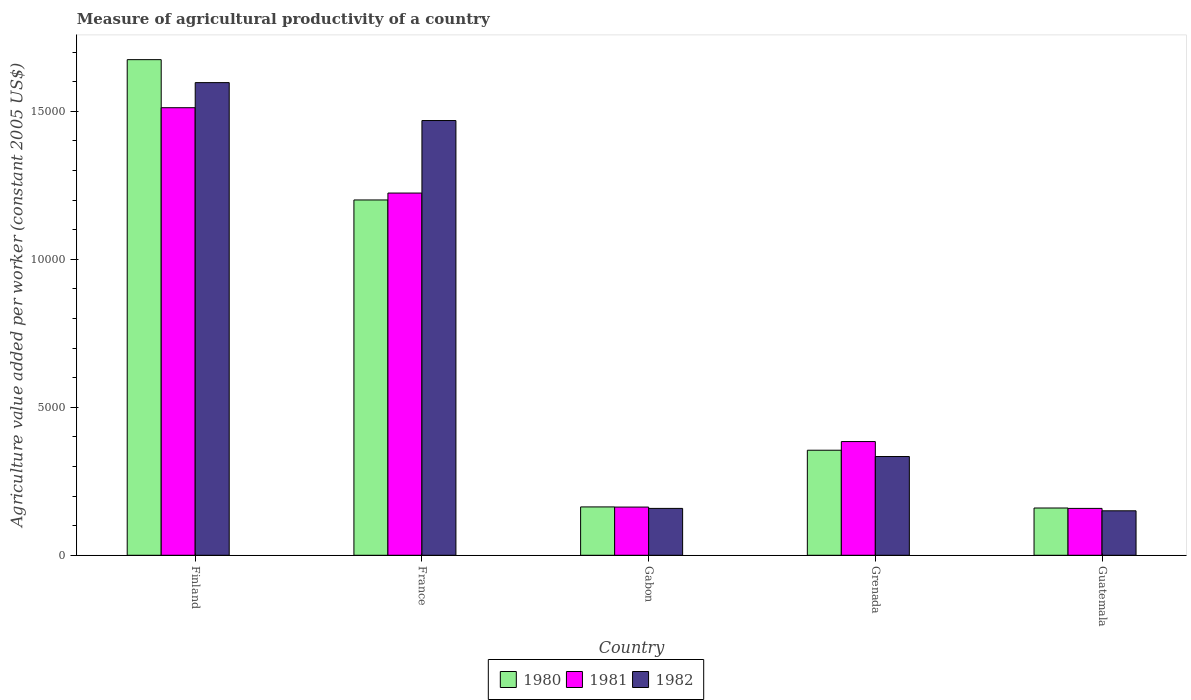How many different coloured bars are there?
Keep it short and to the point. 3. How many groups of bars are there?
Make the answer very short. 5. How many bars are there on the 5th tick from the left?
Provide a short and direct response. 3. How many bars are there on the 4th tick from the right?
Make the answer very short. 3. What is the label of the 2nd group of bars from the left?
Keep it short and to the point. France. What is the measure of agricultural productivity in 1982 in Grenada?
Make the answer very short. 3337.18. Across all countries, what is the maximum measure of agricultural productivity in 1980?
Your answer should be very brief. 1.67e+04. Across all countries, what is the minimum measure of agricultural productivity in 1980?
Your response must be concise. 1597.56. In which country was the measure of agricultural productivity in 1980 maximum?
Offer a very short reply. Finland. In which country was the measure of agricultural productivity in 1982 minimum?
Your answer should be compact. Guatemala. What is the total measure of agricultural productivity in 1982 in the graph?
Offer a very short reply. 3.71e+04. What is the difference between the measure of agricultural productivity in 1980 in France and that in Grenada?
Provide a succinct answer. 8457.31. What is the difference between the measure of agricultural productivity in 1982 in Gabon and the measure of agricultural productivity in 1980 in Grenada?
Ensure brevity in your answer.  -1966.16. What is the average measure of agricultural productivity in 1980 per country?
Keep it short and to the point. 7107.71. What is the difference between the measure of agricultural productivity of/in 1982 and measure of agricultural productivity of/in 1980 in France?
Your response must be concise. 2683.77. What is the ratio of the measure of agricultural productivity in 1981 in Finland to that in France?
Keep it short and to the point. 1.24. Is the measure of agricultural productivity in 1981 in Finland less than that in France?
Your answer should be compact. No. What is the difference between the highest and the second highest measure of agricultural productivity in 1980?
Your answer should be compact. 1.32e+04. What is the difference between the highest and the lowest measure of agricultural productivity in 1980?
Your answer should be compact. 1.52e+04. In how many countries, is the measure of agricultural productivity in 1980 greater than the average measure of agricultural productivity in 1980 taken over all countries?
Your answer should be very brief. 2. Is it the case that in every country, the sum of the measure of agricultural productivity in 1982 and measure of agricultural productivity in 1980 is greater than the measure of agricultural productivity in 1981?
Give a very brief answer. Yes. How many bars are there?
Provide a short and direct response. 15. How many countries are there in the graph?
Give a very brief answer. 5. Are the values on the major ticks of Y-axis written in scientific E-notation?
Keep it short and to the point. No. Where does the legend appear in the graph?
Your answer should be compact. Bottom center. How many legend labels are there?
Offer a very short reply. 3. What is the title of the graph?
Give a very brief answer. Measure of agricultural productivity of a country. What is the label or title of the X-axis?
Keep it short and to the point. Country. What is the label or title of the Y-axis?
Provide a succinct answer. Agriculture value added per worker (constant 2005 US$). What is the Agriculture value added per worker (constant 2005 US$) of 1980 in Finland?
Your response must be concise. 1.67e+04. What is the Agriculture value added per worker (constant 2005 US$) of 1981 in Finland?
Provide a succinct answer. 1.51e+04. What is the Agriculture value added per worker (constant 2005 US$) of 1982 in Finland?
Ensure brevity in your answer.  1.60e+04. What is the Agriculture value added per worker (constant 2005 US$) of 1980 in France?
Offer a very short reply. 1.20e+04. What is the Agriculture value added per worker (constant 2005 US$) in 1981 in France?
Your response must be concise. 1.22e+04. What is the Agriculture value added per worker (constant 2005 US$) in 1982 in France?
Ensure brevity in your answer.  1.47e+04. What is the Agriculture value added per worker (constant 2005 US$) in 1980 in Gabon?
Your answer should be very brief. 1634.34. What is the Agriculture value added per worker (constant 2005 US$) of 1981 in Gabon?
Your answer should be very brief. 1629.22. What is the Agriculture value added per worker (constant 2005 US$) of 1982 in Gabon?
Your answer should be compact. 1584.05. What is the Agriculture value added per worker (constant 2005 US$) of 1980 in Grenada?
Offer a very short reply. 3550.21. What is the Agriculture value added per worker (constant 2005 US$) of 1981 in Grenada?
Keep it short and to the point. 3843.2. What is the Agriculture value added per worker (constant 2005 US$) in 1982 in Grenada?
Your answer should be compact. 3337.18. What is the Agriculture value added per worker (constant 2005 US$) of 1980 in Guatemala?
Make the answer very short. 1597.56. What is the Agriculture value added per worker (constant 2005 US$) of 1981 in Guatemala?
Provide a short and direct response. 1584.31. What is the Agriculture value added per worker (constant 2005 US$) in 1982 in Guatemala?
Your response must be concise. 1502.82. Across all countries, what is the maximum Agriculture value added per worker (constant 2005 US$) in 1980?
Offer a terse response. 1.67e+04. Across all countries, what is the maximum Agriculture value added per worker (constant 2005 US$) in 1981?
Keep it short and to the point. 1.51e+04. Across all countries, what is the maximum Agriculture value added per worker (constant 2005 US$) in 1982?
Ensure brevity in your answer.  1.60e+04. Across all countries, what is the minimum Agriculture value added per worker (constant 2005 US$) of 1980?
Provide a short and direct response. 1597.56. Across all countries, what is the minimum Agriculture value added per worker (constant 2005 US$) in 1981?
Your response must be concise. 1584.31. Across all countries, what is the minimum Agriculture value added per worker (constant 2005 US$) in 1982?
Provide a succinct answer. 1502.82. What is the total Agriculture value added per worker (constant 2005 US$) in 1980 in the graph?
Offer a terse response. 3.55e+04. What is the total Agriculture value added per worker (constant 2005 US$) of 1981 in the graph?
Keep it short and to the point. 3.44e+04. What is the total Agriculture value added per worker (constant 2005 US$) in 1982 in the graph?
Your answer should be compact. 3.71e+04. What is the difference between the Agriculture value added per worker (constant 2005 US$) of 1980 in Finland and that in France?
Your response must be concise. 4741.4. What is the difference between the Agriculture value added per worker (constant 2005 US$) of 1981 in Finland and that in France?
Offer a terse response. 2884.02. What is the difference between the Agriculture value added per worker (constant 2005 US$) of 1982 in Finland and that in France?
Offer a terse response. 1281.43. What is the difference between the Agriculture value added per worker (constant 2005 US$) in 1980 in Finland and that in Gabon?
Your answer should be compact. 1.51e+04. What is the difference between the Agriculture value added per worker (constant 2005 US$) of 1981 in Finland and that in Gabon?
Provide a short and direct response. 1.35e+04. What is the difference between the Agriculture value added per worker (constant 2005 US$) of 1982 in Finland and that in Gabon?
Your answer should be compact. 1.44e+04. What is the difference between the Agriculture value added per worker (constant 2005 US$) of 1980 in Finland and that in Grenada?
Offer a very short reply. 1.32e+04. What is the difference between the Agriculture value added per worker (constant 2005 US$) of 1981 in Finland and that in Grenada?
Provide a short and direct response. 1.13e+04. What is the difference between the Agriculture value added per worker (constant 2005 US$) in 1982 in Finland and that in Grenada?
Offer a terse response. 1.26e+04. What is the difference between the Agriculture value added per worker (constant 2005 US$) of 1980 in Finland and that in Guatemala?
Keep it short and to the point. 1.52e+04. What is the difference between the Agriculture value added per worker (constant 2005 US$) of 1981 in Finland and that in Guatemala?
Offer a terse response. 1.35e+04. What is the difference between the Agriculture value added per worker (constant 2005 US$) in 1982 in Finland and that in Guatemala?
Keep it short and to the point. 1.45e+04. What is the difference between the Agriculture value added per worker (constant 2005 US$) of 1980 in France and that in Gabon?
Your answer should be very brief. 1.04e+04. What is the difference between the Agriculture value added per worker (constant 2005 US$) in 1981 in France and that in Gabon?
Your answer should be very brief. 1.06e+04. What is the difference between the Agriculture value added per worker (constant 2005 US$) in 1982 in France and that in Gabon?
Give a very brief answer. 1.31e+04. What is the difference between the Agriculture value added per worker (constant 2005 US$) in 1980 in France and that in Grenada?
Your answer should be compact. 8457.31. What is the difference between the Agriculture value added per worker (constant 2005 US$) in 1981 in France and that in Grenada?
Offer a terse response. 8397.81. What is the difference between the Agriculture value added per worker (constant 2005 US$) in 1982 in France and that in Grenada?
Provide a succinct answer. 1.14e+04. What is the difference between the Agriculture value added per worker (constant 2005 US$) of 1980 in France and that in Guatemala?
Provide a short and direct response. 1.04e+04. What is the difference between the Agriculture value added per worker (constant 2005 US$) in 1981 in France and that in Guatemala?
Offer a terse response. 1.07e+04. What is the difference between the Agriculture value added per worker (constant 2005 US$) of 1982 in France and that in Guatemala?
Make the answer very short. 1.32e+04. What is the difference between the Agriculture value added per worker (constant 2005 US$) in 1980 in Gabon and that in Grenada?
Your response must be concise. -1915.87. What is the difference between the Agriculture value added per worker (constant 2005 US$) of 1981 in Gabon and that in Grenada?
Provide a short and direct response. -2213.98. What is the difference between the Agriculture value added per worker (constant 2005 US$) in 1982 in Gabon and that in Grenada?
Your response must be concise. -1753.13. What is the difference between the Agriculture value added per worker (constant 2005 US$) in 1980 in Gabon and that in Guatemala?
Keep it short and to the point. 36.78. What is the difference between the Agriculture value added per worker (constant 2005 US$) of 1981 in Gabon and that in Guatemala?
Your response must be concise. 44.92. What is the difference between the Agriculture value added per worker (constant 2005 US$) in 1982 in Gabon and that in Guatemala?
Provide a succinct answer. 81.23. What is the difference between the Agriculture value added per worker (constant 2005 US$) in 1980 in Grenada and that in Guatemala?
Your response must be concise. 1952.65. What is the difference between the Agriculture value added per worker (constant 2005 US$) in 1981 in Grenada and that in Guatemala?
Make the answer very short. 2258.89. What is the difference between the Agriculture value added per worker (constant 2005 US$) in 1982 in Grenada and that in Guatemala?
Give a very brief answer. 1834.36. What is the difference between the Agriculture value added per worker (constant 2005 US$) in 1980 in Finland and the Agriculture value added per worker (constant 2005 US$) in 1981 in France?
Your answer should be compact. 4507.91. What is the difference between the Agriculture value added per worker (constant 2005 US$) of 1980 in Finland and the Agriculture value added per worker (constant 2005 US$) of 1982 in France?
Offer a very short reply. 2057.63. What is the difference between the Agriculture value added per worker (constant 2005 US$) in 1981 in Finland and the Agriculture value added per worker (constant 2005 US$) in 1982 in France?
Your answer should be very brief. 433.74. What is the difference between the Agriculture value added per worker (constant 2005 US$) of 1980 in Finland and the Agriculture value added per worker (constant 2005 US$) of 1981 in Gabon?
Your answer should be compact. 1.51e+04. What is the difference between the Agriculture value added per worker (constant 2005 US$) in 1980 in Finland and the Agriculture value added per worker (constant 2005 US$) in 1982 in Gabon?
Keep it short and to the point. 1.52e+04. What is the difference between the Agriculture value added per worker (constant 2005 US$) of 1981 in Finland and the Agriculture value added per worker (constant 2005 US$) of 1982 in Gabon?
Offer a terse response. 1.35e+04. What is the difference between the Agriculture value added per worker (constant 2005 US$) of 1980 in Finland and the Agriculture value added per worker (constant 2005 US$) of 1981 in Grenada?
Your answer should be very brief. 1.29e+04. What is the difference between the Agriculture value added per worker (constant 2005 US$) in 1980 in Finland and the Agriculture value added per worker (constant 2005 US$) in 1982 in Grenada?
Ensure brevity in your answer.  1.34e+04. What is the difference between the Agriculture value added per worker (constant 2005 US$) in 1981 in Finland and the Agriculture value added per worker (constant 2005 US$) in 1982 in Grenada?
Provide a short and direct response. 1.18e+04. What is the difference between the Agriculture value added per worker (constant 2005 US$) in 1980 in Finland and the Agriculture value added per worker (constant 2005 US$) in 1981 in Guatemala?
Your answer should be very brief. 1.52e+04. What is the difference between the Agriculture value added per worker (constant 2005 US$) of 1980 in Finland and the Agriculture value added per worker (constant 2005 US$) of 1982 in Guatemala?
Offer a very short reply. 1.52e+04. What is the difference between the Agriculture value added per worker (constant 2005 US$) in 1981 in Finland and the Agriculture value added per worker (constant 2005 US$) in 1982 in Guatemala?
Offer a very short reply. 1.36e+04. What is the difference between the Agriculture value added per worker (constant 2005 US$) in 1980 in France and the Agriculture value added per worker (constant 2005 US$) in 1981 in Gabon?
Your response must be concise. 1.04e+04. What is the difference between the Agriculture value added per worker (constant 2005 US$) of 1980 in France and the Agriculture value added per worker (constant 2005 US$) of 1982 in Gabon?
Your answer should be compact. 1.04e+04. What is the difference between the Agriculture value added per worker (constant 2005 US$) of 1981 in France and the Agriculture value added per worker (constant 2005 US$) of 1982 in Gabon?
Your answer should be very brief. 1.07e+04. What is the difference between the Agriculture value added per worker (constant 2005 US$) in 1980 in France and the Agriculture value added per worker (constant 2005 US$) in 1981 in Grenada?
Your response must be concise. 8164.32. What is the difference between the Agriculture value added per worker (constant 2005 US$) of 1980 in France and the Agriculture value added per worker (constant 2005 US$) of 1982 in Grenada?
Offer a terse response. 8670.34. What is the difference between the Agriculture value added per worker (constant 2005 US$) of 1981 in France and the Agriculture value added per worker (constant 2005 US$) of 1982 in Grenada?
Give a very brief answer. 8903.83. What is the difference between the Agriculture value added per worker (constant 2005 US$) of 1980 in France and the Agriculture value added per worker (constant 2005 US$) of 1981 in Guatemala?
Offer a very short reply. 1.04e+04. What is the difference between the Agriculture value added per worker (constant 2005 US$) of 1980 in France and the Agriculture value added per worker (constant 2005 US$) of 1982 in Guatemala?
Provide a short and direct response. 1.05e+04. What is the difference between the Agriculture value added per worker (constant 2005 US$) in 1981 in France and the Agriculture value added per worker (constant 2005 US$) in 1982 in Guatemala?
Make the answer very short. 1.07e+04. What is the difference between the Agriculture value added per worker (constant 2005 US$) in 1980 in Gabon and the Agriculture value added per worker (constant 2005 US$) in 1981 in Grenada?
Provide a succinct answer. -2208.86. What is the difference between the Agriculture value added per worker (constant 2005 US$) in 1980 in Gabon and the Agriculture value added per worker (constant 2005 US$) in 1982 in Grenada?
Ensure brevity in your answer.  -1702.83. What is the difference between the Agriculture value added per worker (constant 2005 US$) in 1981 in Gabon and the Agriculture value added per worker (constant 2005 US$) in 1982 in Grenada?
Ensure brevity in your answer.  -1707.95. What is the difference between the Agriculture value added per worker (constant 2005 US$) of 1980 in Gabon and the Agriculture value added per worker (constant 2005 US$) of 1981 in Guatemala?
Give a very brief answer. 50.04. What is the difference between the Agriculture value added per worker (constant 2005 US$) of 1980 in Gabon and the Agriculture value added per worker (constant 2005 US$) of 1982 in Guatemala?
Keep it short and to the point. 131.53. What is the difference between the Agriculture value added per worker (constant 2005 US$) of 1981 in Gabon and the Agriculture value added per worker (constant 2005 US$) of 1982 in Guatemala?
Offer a terse response. 126.41. What is the difference between the Agriculture value added per worker (constant 2005 US$) in 1980 in Grenada and the Agriculture value added per worker (constant 2005 US$) in 1981 in Guatemala?
Keep it short and to the point. 1965.91. What is the difference between the Agriculture value added per worker (constant 2005 US$) of 1980 in Grenada and the Agriculture value added per worker (constant 2005 US$) of 1982 in Guatemala?
Offer a very short reply. 2047.4. What is the difference between the Agriculture value added per worker (constant 2005 US$) of 1981 in Grenada and the Agriculture value added per worker (constant 2005 US$) of 1982 in Guatemala?
Provide a short and direct response. 2340.38. What is the average Agriculture value added per worker (constant 2005 US$) in 1980 per country?
Ensure brevity in your answer.  7107.71. What is the average Agriculture value added per worker (constant 2005 US$) of 1981 per country?
Your answer should be very brief. 6884.55. What is the average Agriculture value added per worker (constant 2005 US$) of 1982 per country?
Give a very brief answer. 7417.61. What is the difference between the Agriculture value added per worker (constant 2005 US$) in 1980 and Agriculture value added per worker (constant 2005 US$) in 1981 in Finland?
Your response must be concise. 1623.89. What is the difference between the Agriculture value added per worker (constant 2005 US$) in 1980 and Agriculture value added per worker (constant 2005 US$) in 1982 in Finland?
Your answer should be very brief. 776.2. What is the difference between the Agriculture value added per worker (constant 2005 US$) of 1981 and Agriculture value added per worker (constant 2005 US$) of 1982 in Finland?
Your answer should be very brief. -847.68. What is the difference between the Agriculture value added per worker (constant 2005 US$) in 1980 and Agriculture value added per worker (constant 2005 US$) in 1981 in France?
Make the answer very short. -233.49. What is the difference between the Agriculture value added per worker (constant 2005 US$) in 1980 and Agriculture value added per worker (constant 2005 US$) in 1982 in France?
Ensure brevity in your answer.  -2683.77. What is the difference between the Agriculture value added per worker (constant 2005 US$) in 1981 and Agriculture value added per worker (constant 2005 US$) in 1982 in France?
Give a very brief answer. -2450.28. What is the difference between the Agriculture value added per worker (constant 2005 US$) in 1980 and Agriculture value added per worker (constant 2005 US$) in 1981 in Gabon?
Ensure brevity in your answer.  5.12. What is the difference between the Agriculture value added per worker (constant 2005 US$) of 1980 and Agriculture value added per worker (constant 2005 US$) of 1982 in Gabon?
Your response must be concise. 50.29. What is the difference between the Agriculture value added per worker (constant 2005 US$) of 1981 and Agriculture value added per worker (constant 2005 US$) of 1982 in Gabon?
Your response must be concise. 45.17. What is the difference between the Agriculture value added per worker (constant 2005 US$) in 1980 and Agriculture value added per worker (constant 2005 US$) in 1981 in Grenada?
Your response must be concise. -292.99. What is the difference between the Agriculture value added per worker (constant 2005 US$) in 1980 and Agriculture value added per worker (constant 2005 US$) in 1982 in Grenada?
Give a very brief answer. 213.04. What is the difference between the Agriculture value added per worker (constant 2005 US$) of 1981 and Agriculture value added per worker (constant 2005 US$) of 1982 in Grenada?
Your response must be concise. 506.02. What is the difference between the Agriculture value added per worker (constant 2005 US$) of 1980 and Agriculture value added per worker (constant 2005 US$) of 1981 in Guatemala?
Offer a very short reply. 13.25. What is the difference between the Agriculture value added per worker (constant 2005 US$) in 1980 and Agriculture value added per worker (constant 2005 US$) in 1982 in Guatemala?
Give a very brief answer. 94.74. What is the difference between the Agriculture value added per worker (constant 2005 US$) of 1981 and Agriculture value added per worker (constant 2005 US$) of 1982 in Guatemala?
Your answer should be compact. 81.49. What is the ratio of the Agriculture value added per worker (constant 2005 US$) in 1980 in Finland to that in France?
Your answer should be compact. 1.39. What is the ratio of the Agriculture value added per worker (constant 2005 US$) in 1981 in Finland to that in France?
Keep it short and to the point. 1.24. What is the ratio of the Agriculture value added per worker (constant 2005 US$) in 1982 in Finland to that in France?
Your answer should be very brief. 1.09. What is the ratio of the Agriculture value added per worker (constant 2005 US$) of 1980 in Finland to that in Gabon?
Give a very brief answer. 10.25. What is the ratio of the Agriculture value added per worker (constant 2005 US$) in 1981 in Finland to that in Gabon?
Provide a succinct answer. 9.28. What is the ratio of the Agriculture value added per worker (constant 2005 US$) in 1982 in Finland to that in Gabon?
Give a very brief answer. 10.08. What is the ratio of the Agriculture value added per worker (constant 2005 US$) of 1980 in Finland to that in Grenada?
Keep it short and to the point. 4.72. What is the ratio of the Agriculture value added per worker (constant 2005 US$) in 1981 in Finland to that in Grenada?
Provide a short and direct response. 3.94. What is the ratio of the Agriculture value added per worker (constant 2005 US$) in 1982 in Finland to that in Grenada?
Provide a short and direct response. 4.79. What is the ratio of the Agriculture value added per worker (constant 2005 US$) in 1980 in Finland to that in Guatemala?
Offer a very short reply. 10.48. What is the ratio of the Agriculture value added per worker (constant 2005 US$) in 1981 in Finland to that in Guatemala?
Keep it short and to the point. 9.55. What is the ratio of the Agriculture value added per worker (constant 2005 US$) in 1982 in Finland to that in Guatemala?
Offer a very short reply. 10.63. What is the ratio of the Agriculture value added per worker (constant 2005 US$) in 1980 in France to that in Gabon?
Make the answer very short. 7.35. What is the ratio of the Agriculture value added per worker (constant 2005 US$) of 1981 in France to that in Gabon?
Your answer should be compact. 7.51. What is the ratio of the Agriculture value added per worker (constant 2005 US$) in 1982 in France to that in Gabon?
Give a very brief answer. 9.27. What is the ratio of the Agriculture value added per worker (constant 2005 US$) of 1980 in France to that in Grenada?
Make the answer very short. 3.38. What is the ratio of the Agriculture value added per worker (constant 2005 US$) of 1981 in France to that in Grenada?
Your response must be concise. 3.19. What is the ratio of the Agriculture value added per worker (constant 2005 US$) of 1982 in France to that in Grenada?
Your answer should be very brief. 4.4. What is the ratio of the Agriculture value added per worker (constant 2005 US$) in 1980 in France to that in Guatemala?
Give a very brief answer. 7.52. What is the ratio of the Agriculture value added per worker (constant 2005 US$) in 1981 in France to that in Guatemala?
Make the answer very short. 7.73. What is the ratio of the Agriculture value added per worker (constant 2005 US$) of 1982 in France to that in Guatemala?
Your answer should be compact. 9.78. What is the ratio of the Agriculture value added per worker (constant 2005 US$) in 1980 in Gabon to that in Grenada?
Offer a terse response. 0.46. What is the ratio of the Agriculture value added per worker (constant 2005 US$) in 1981 in Gabon to that in Grenada?
Give a very brief answer. 0.42. What is the ratio of the Agriculture value added per worker (constant 2005 US$) in 1982 in Gabon to that in Grenada?
Keep it short and to the point. 0.47. What is the ratio of the Agriculture value added per worker (constant 2005 US$) in 1980 in Gabon to that in Guatemala?
Ensure brevity in your answer.  1.02. What is the ratio of the Agriculture value added per worker (constant 2005 US$) in 1981 in Gabon to that in Guatemala?
Keep it short and to the point. 1.03. What is the ratio of the Agriculture value added per worker (constant 2005 US$) in 1982 in Gabon to that in Guatemala?
Provide a short and direct response. 1.05. What is the ratio of the Agriculture value added per worker (constant 2005 US$) in 1980 in Grenada to that in Guatemala?
Keep it short and to the point. 2.22. What is the ratio of the Agriculture value added per worker (constant 2005 US$) in 1981 in Grenada to that in Guatemala?
Provide a succinct answer. 2.43. What is the ratio of the Agriculture value added per worker (constant 2005 US$) in 1982 in Grenada to that in Guatemala?
Provide a succinct answer. 2.22. What is the difference between the highest and the second highest Agriculture value added per worker (constant 2005 US$) of 1980?
Provide a succinct answer. 4741.4. What is the difference between the highest and the second highest Agriculture value added per worker (constant 2005 US$) in 1981?
Provide a short and direct response. 2884.02. What is the difference between the highest and the second highest Agriculture value added per worker (constant 2005 US$) of 1982?
Your answer should be very brief. 1281.43. What is the difference between the highest and the lowest Agriculture value added per worker (constant 2005 US$) in 1980?
Give a very brief answer. 1.52e+04. What is the difference between the highest and the lowest Agriculture value added per worker (constant 2005 US$) in 1981?
Provide a succinct answer. 1.35e+04. What is the difference between the highest and the lowest Agriculture value added per worker (constant 2005 US$) of 1982?
Give a very brief answer. 1.45e+04. 